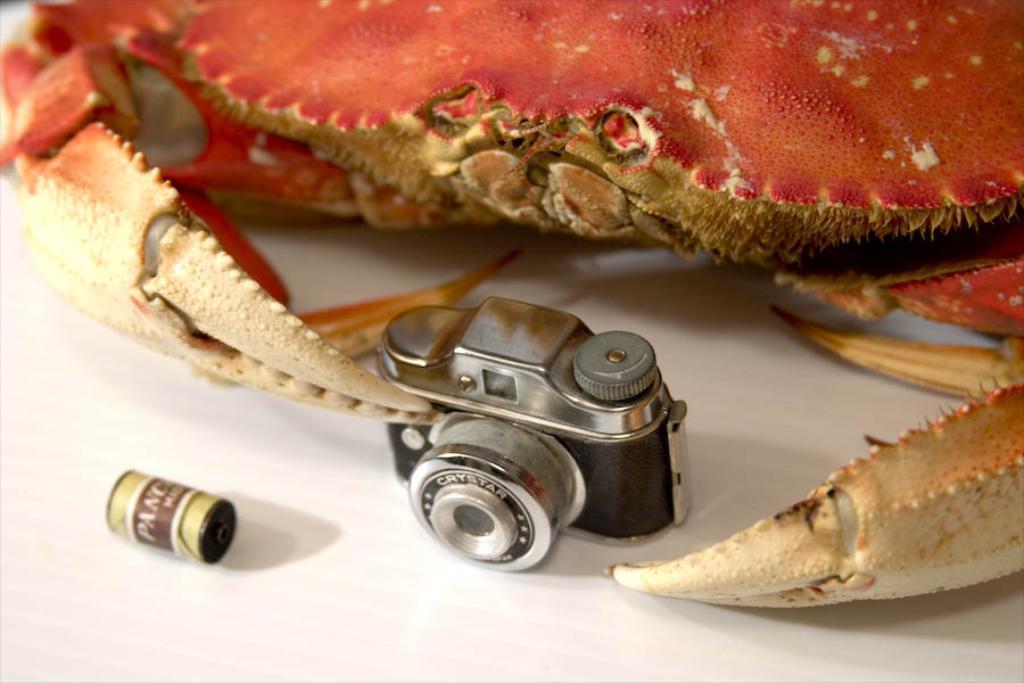Describe this image in one or two sentences. In this image we can see a crab, a camera and one object on the white color surface. 